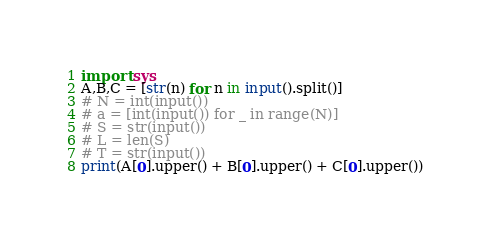Convert code to text. <code><loc_0><loc_0><loc_500><loc_500><_Python_>import sys
A,B,C = [str(n) for n in input().split()]
# N = int(input())
# a = [int(input()) for _ in range(N)]
# S = str(input())
# L = len(S)
# T = str(input())
print(A[0].upper() + B[0].upper() + C[0].upper())
</code> 